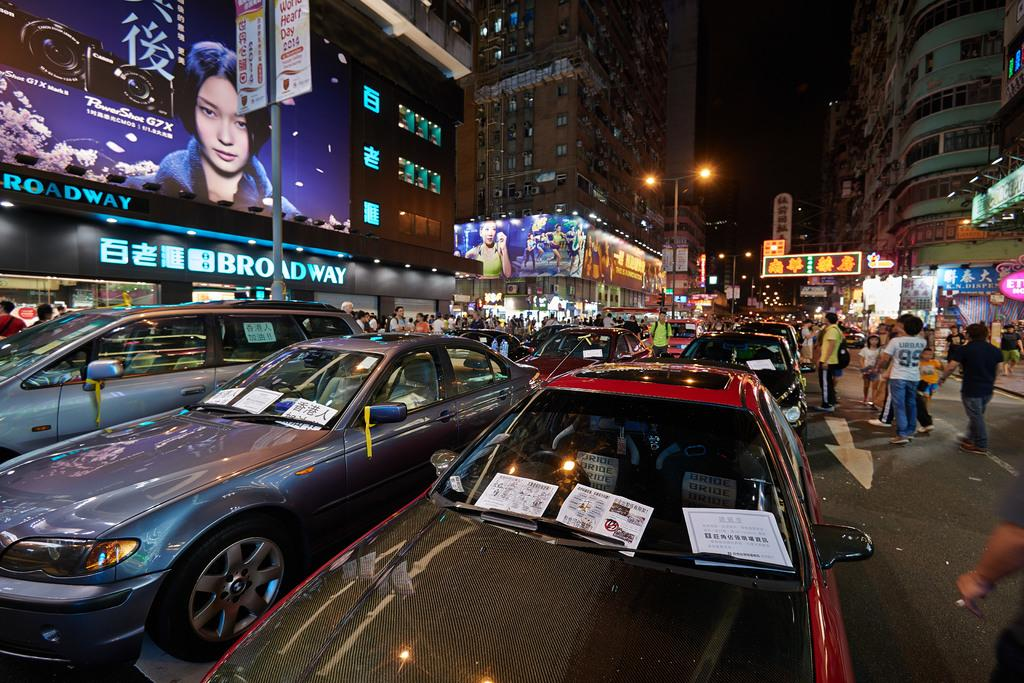<image>
Summarize the visual content of the image. A person in the street is wearing a number 99 shirt. 